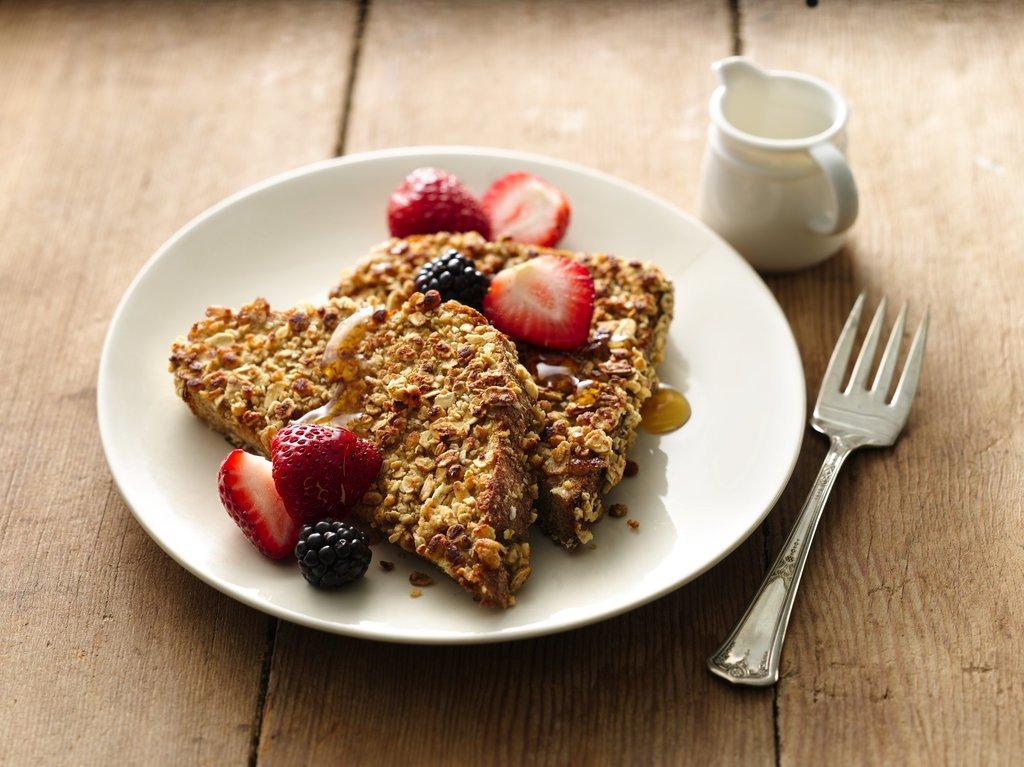Can you describe this image briefly? In this image I can see few food items in the plate and the food items are in brown, pink and black color and I can also see the cup and the spoon on the brown color surface. 